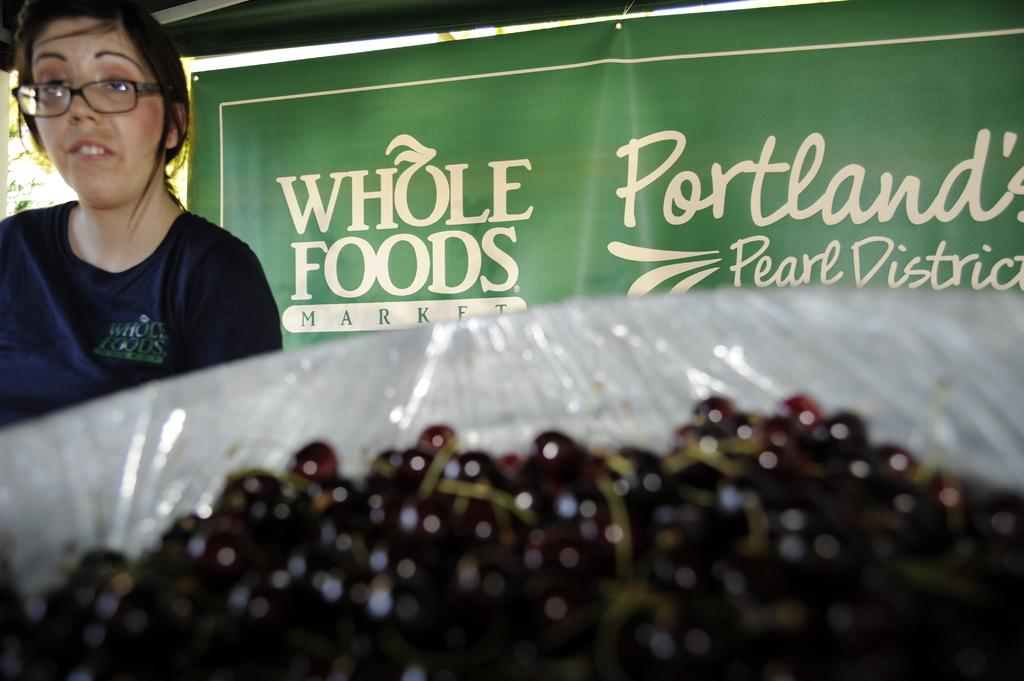What type of fruit is in the basket in the image? There are berries in a basket in the image. Can you describe the woman on the left side of the image? There is a woman wearing glasses on the left side of the image. What can be seen in the background of the image? There is a banner in the background of the image. How many frogs are sitting on the woman's hand in the image? There are no frogs present in the image, and the woman's hand is not visible. What type of slip is the woman wearing in the image? There is no mention of the woman wearing a slip in the image, and her clothing is not described in the provided facts. 